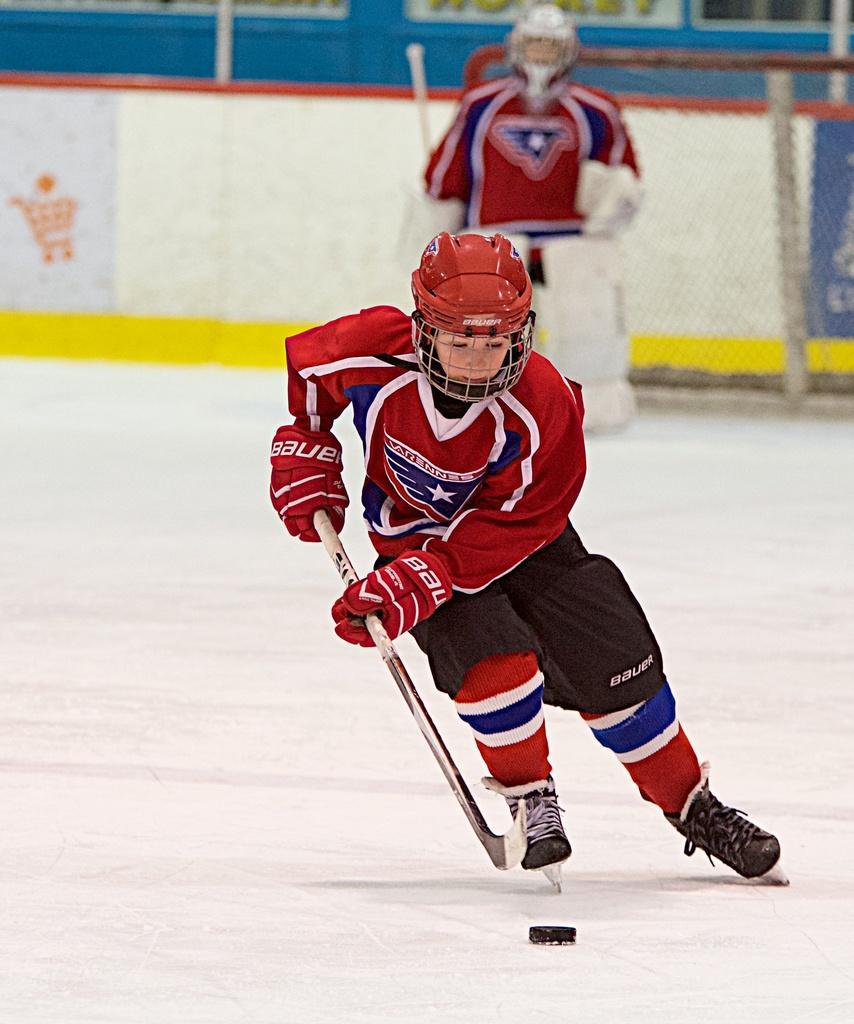How would you summarize this image in a sentence or two? In this image I can see two persons. I can see both of them are wearing red colour dress, helmets, gloves and I can see both of them are holding sticks. I can also see he is wearing black colour skating shoes. Here I can see a black colour thing and I can see this image is little bit blurry from background. 